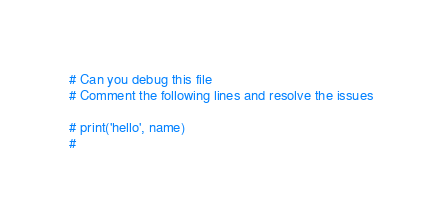<code> <loc_0><loc_0><loc_500><loc_500><_Python_># Can you debug this file
# Comment the following lines and resolve the issues

# print('hello', name)
#</code> 